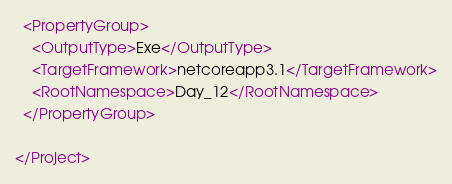Convert code to text. <code><loc_0><loc_0><loc_500><loc_500><_XML_>
  <PropertyGroup>
    <OutputType>Exe</OutputType>
    <TargetFramework>netcoreapp3.1</TargetFramework>
    <RootNamespace>Day_12</RootNamespace>
  </PropertyGroup>

</Project>
</code> 